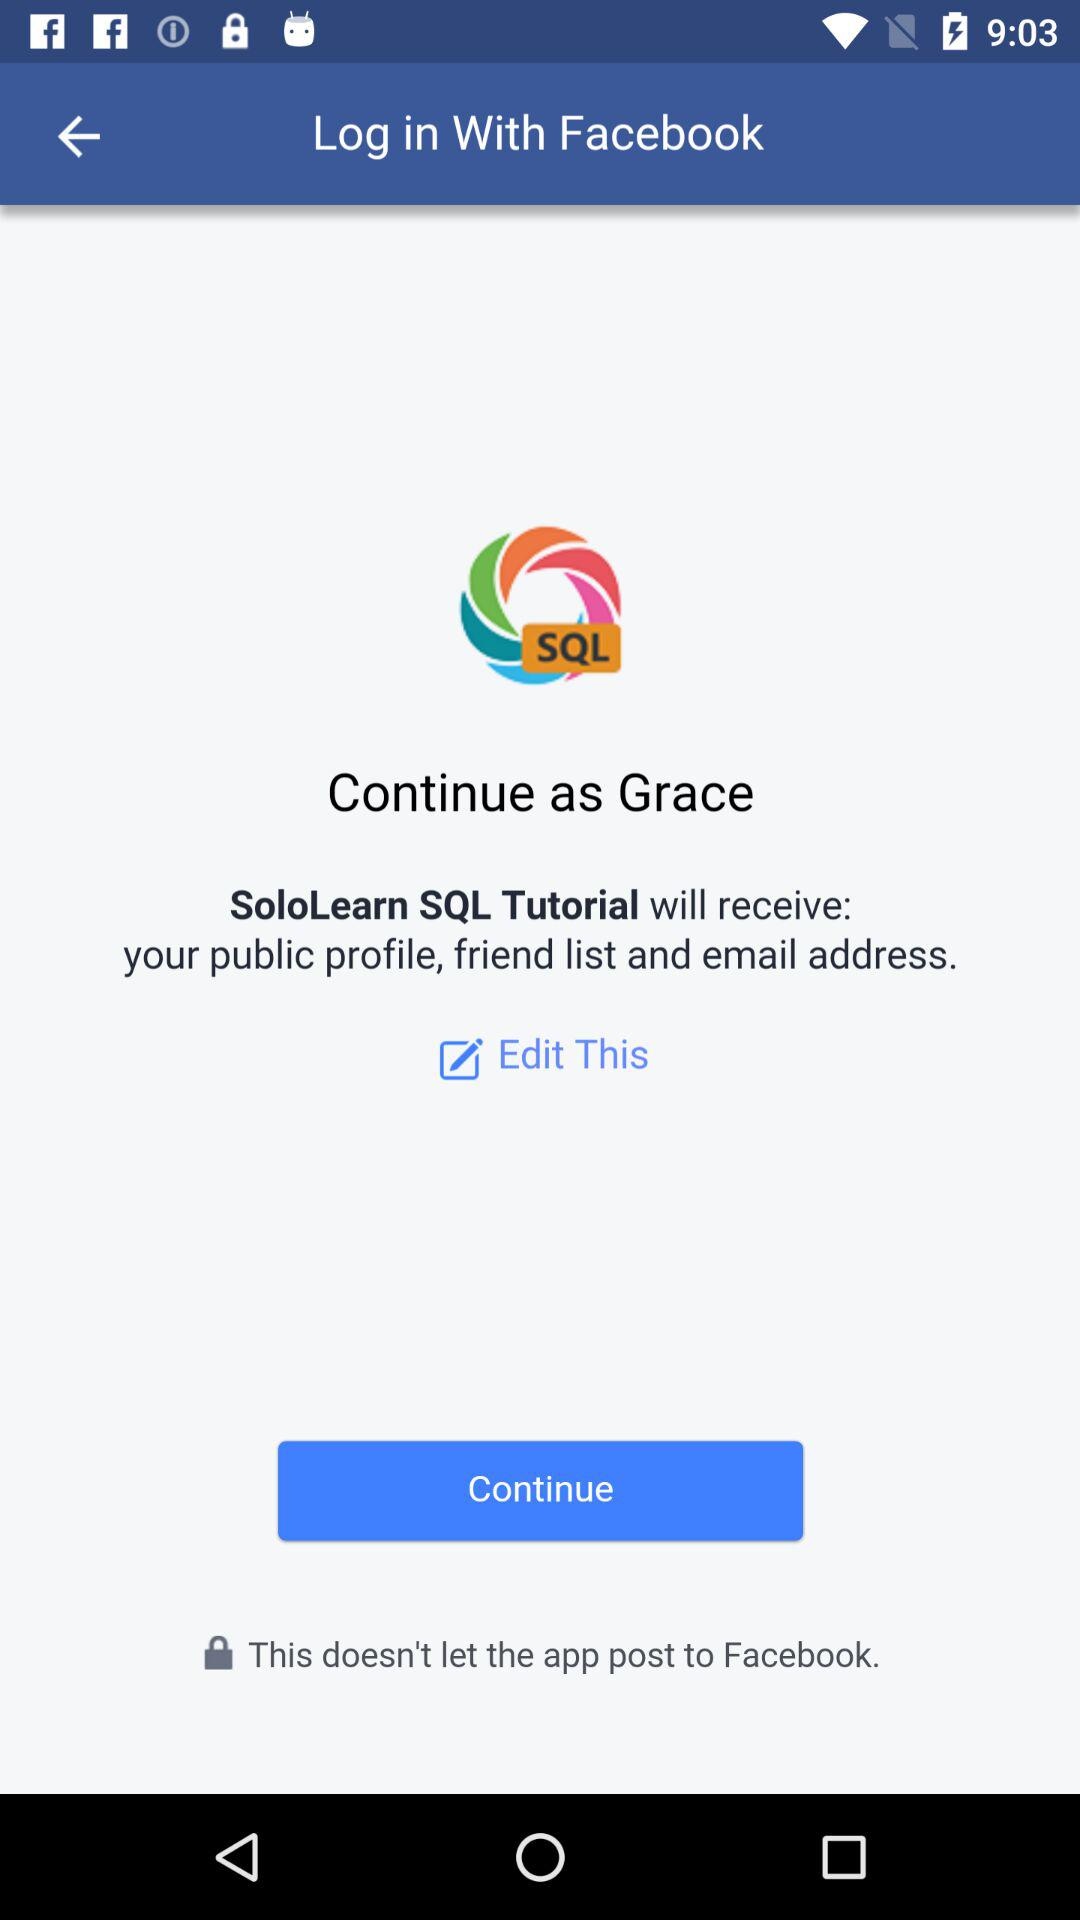What is the login application? The login application is "Facebook". 